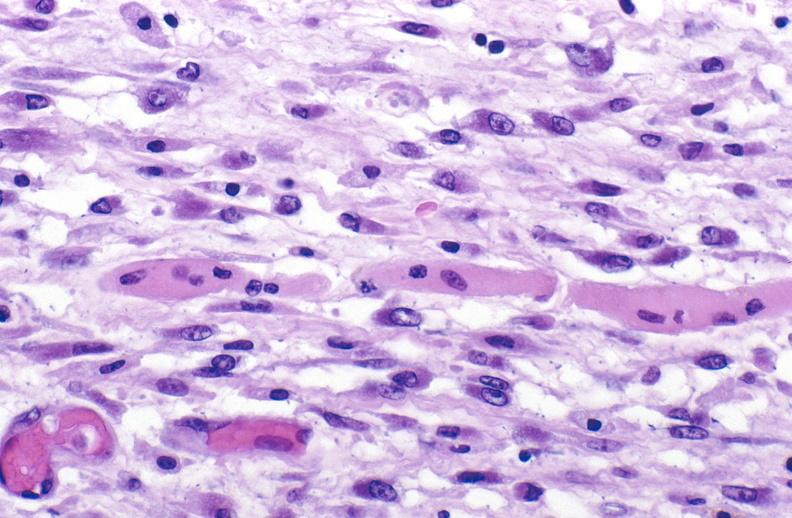s muscle present?
Answer the question using a single word or phrase. Yes 